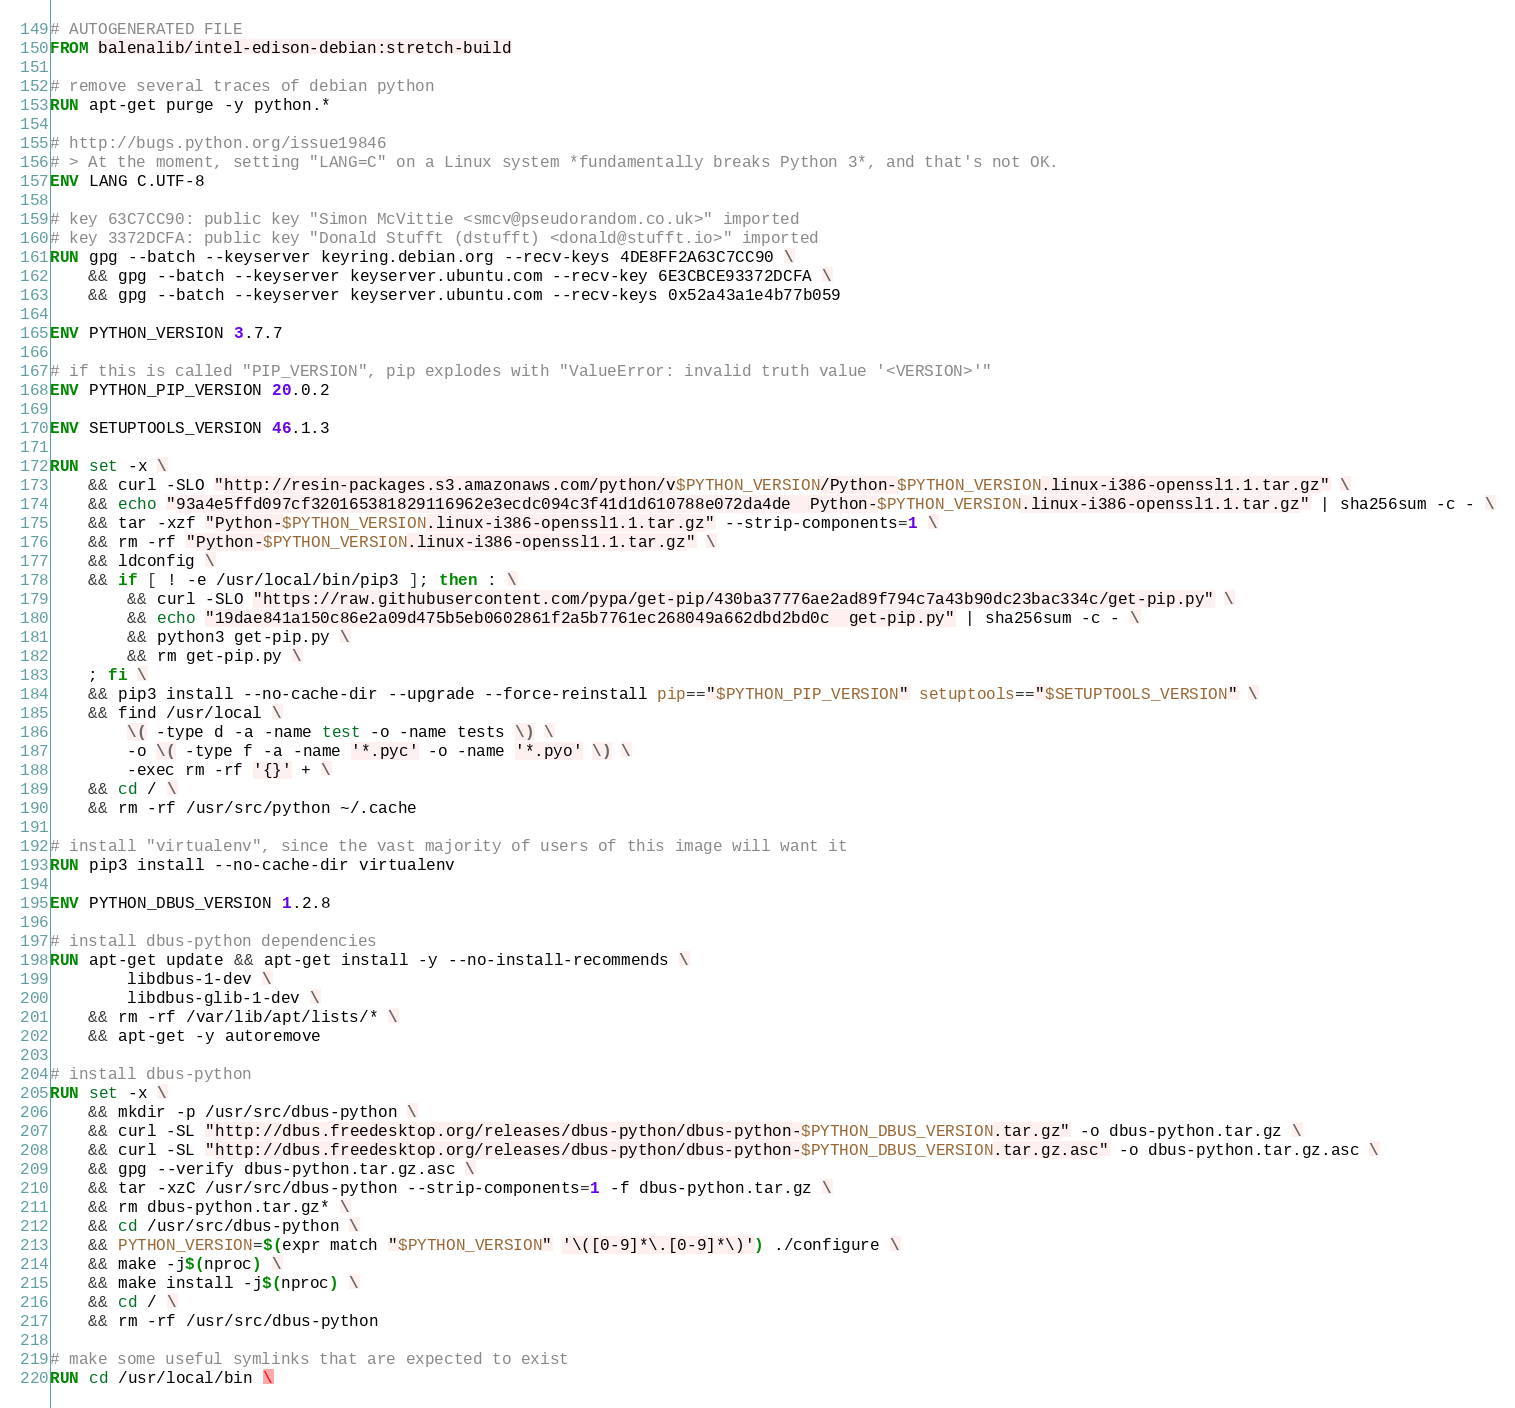<code> <loc_0><loc_0><loc_500><loc_500><_Dockerfile_># AUTOGENERATED FILE
FROM balenalib/intel-edison-debian:stretch-build

# remove several traces of debian python
RUN apt-get purge -y python.*

# http://bugs.python.org/issue19846
# > At the moment, setting "LANG=C" on a Linux system *fundamentally breaks Python 3*, and that's not OK.
ENV LANG C.UTF-8

# key 63C7CC90: public key "Simon McVittie <smcv@pseudorandom.co.uk>" imported
# key 3372DCFA: public key "Donald Stufft (dstufft) <donald@stufft.io>" imported
RUN gpg --batch --keyserver keyring.debian.org --recv-keys 4DE8FF2A63C7CC90 \
	&& gpg --batch --keyserver keyserver.ubuntu.com --recv-key 6E3CBCE93372DCFA \
	&& gpg --batch --keyserver keyserver.ubuntu.com --recv-keys 0x52a43a1e4b77b059

ENV PYTHON_VERSION 3.7.7

# if this is called "PIP_VERSION", pip explodes with "ValueError: invalid truth value '<VERSION>'"
ENV PYTHON_PIP_VERSION 20.0.2

ENV SETUPTOOLS_VERSION 46.1.3

RUN set -x \
	&& curl -SLO "http://resin-packages.s3.amazonaws.com/python/v$PYTHON_VERSION/Python-$PYTHON_VERSION.linux-i386-openssl1.1.tar.gz" \
	&& echo "93a4e5ffd097cf320165381829116962e3ecdc094c3f41d1d610788e072da4de  Python-$PYTHON_VERSION.linux-i386-openssl1.1.tar.gz" | sha256sum -c - \
	&& tar -xzf "Python-$PYTHON_VERSION.linux-i386-openssl1.1.tar.gz" --strip-components=1 \
	&& rm -rf "Python-$PYTHON_VERSION.linux-i386-openssl1.1.tar.gz" \
	&& ldconfig \
	&& if [ ! -e /usr/local/bin/pip3 ]; then : \
		&& curl -SLO "https://raw.githubusercontent.com/pypa/get-pip/430ba37776ae2ad89f794c7a43b90dc23bac334c/get-pip.py" \
		&& echo "19dae841a150c86e2a09d475b5eb0602861f2a5b7761ec268049a662dbd2bd0c  get-pip.py" | sha256sum -c - \
		&& python3 get-pip.py \
		&& rm get-pip.py \
	; fi \
	&& pip3 install --no-cache-dir --upgrade --force-reinstall pip=="$PYTHON_PIP_VERSION" setuptools=="$SETUPTOOLS_VERSION" \
	&& find /usr/local \
		\( -type d -a -name test -o -name tests \) \
		-o \( -type f -a -name '*.pyc' -o -name '*.pyo' \) \
		-exec rm -rf '{}' + \
	&& cd / \
	&& rm -rf /usr/src/python ~/.cache

# install "virtualenv", since the vast majority of users of this image will want it
RUN pip3 install --no-cache-dir virtualenv

ENV PYTHON_DBUS_VERSION 1.2.8

# install dbus-python dependencies 
RUN apt-get update && apt-get install -y --no-install-recommends \
		libdbus-1-dev \
		libdbus-glib-1-dev \
	&& rm -rf /var/lib/apt/lists/* \
	&& apt-get -y autoremove

# install dbus-python
RUN set -x \
	&& mkdir -p /usr/src/dbus-python \
	&& curl -SL "http://dbus.freedesktop.org/releases/dbus-python/dbus-python-$PYTHON_DBUS_VERSION.tar.gz" -o dbus-python.tar.gz \
	&& curl -SL "http://dbus.freedesktop.org/releases/dbus-python/dbus-python-$PYTHON_DBUS_VERSION.tar.gz.asc" -o dbus-python.tar.gz.asc \
	&& gpg --verify dbus-python.tar.gz.asc \
	&& tar -xzC /usr/src/dbus-python --strip-components=1 -f dbus-python.tar.gz \
	&& rm dbus-python.tar.gz* \
	&& cd /usr/src/dbus-python \
	&& PYTHON_VERSION=$(expr match "$PYTHON_VERSION" '\([0-9]*\.[0-9]*\)') ./configure \
	&& make -j$(nproc) \
	&& make install -j$(nproc) \
	&& cd / \
	&& rm -rf /usr/src/dbus-python

# make some useful symlinks that are expected to exist
RUN cd /usr/local/bin \</code> 